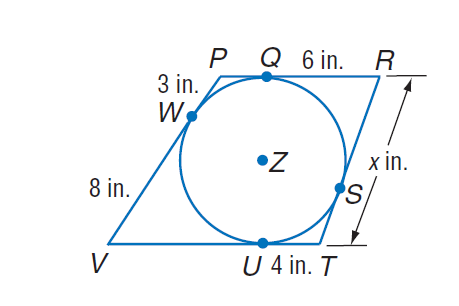Answer the mathemtical geometry problem and directly provide the correct option letter.
Question: Find x. Assume that segments that appear to be tangent are tangent.
Choices: A: 3 B: 6 C: 8 D: 10 D 